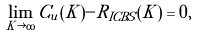Convert formula to latex. <formula><loc_0><loc_0><loc_500><loc_500>\lim _ { K \rightarrow { \infty } } { C _ { u } ( K ) - R _ { I C B S } ( K ) } = 0 ,</formula> 